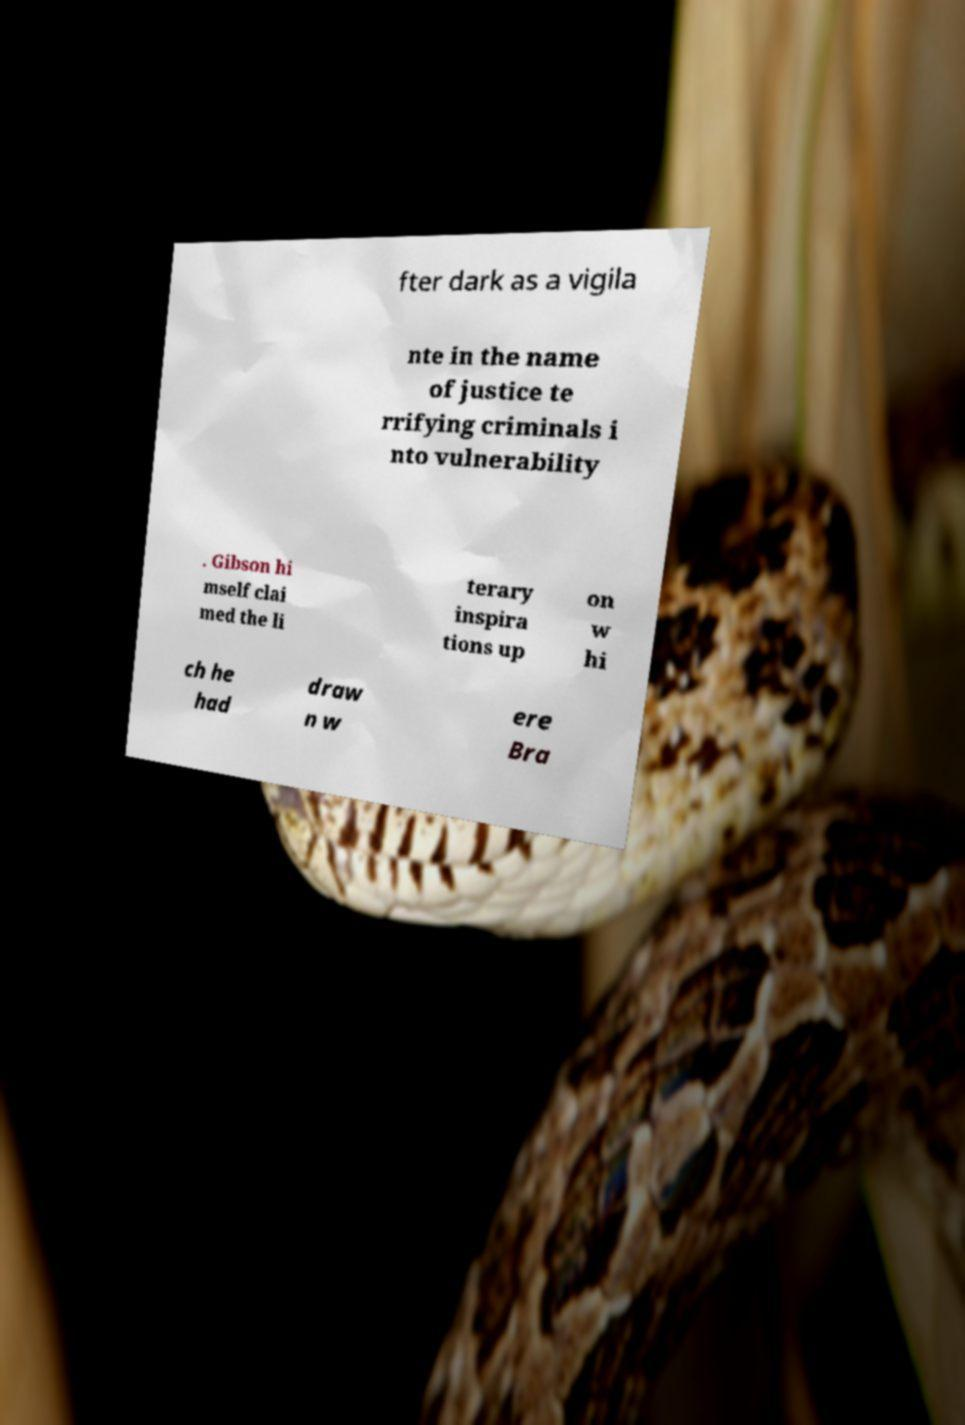Can you read and provide the text displayed in the image?This photo seems to have some interesting text. Can you extract and type it out for me? fter dark as a vigila nte in the name of justice te rrifying criminals i nto vulnerability . Gibson hi mself clai med the li terary inspira tions up on w hi ch he had draw n w ere Bra 